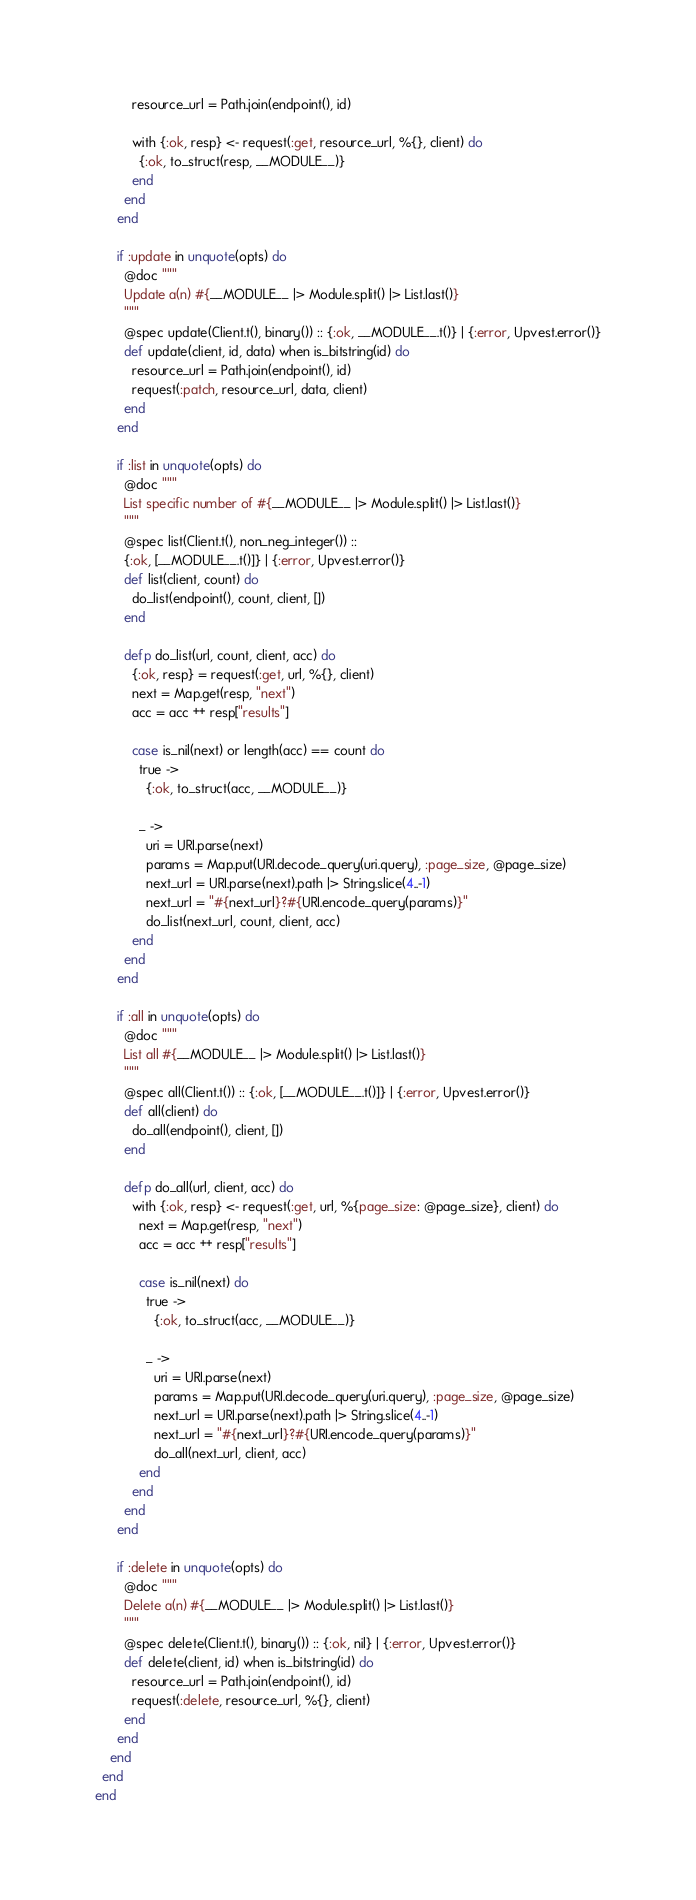Convert code to text. <code><loc_0><loc_0><loc_500><loc_500><_Elixir_>          resource_url = Path.join(endpoint(), id)

          with {:ok, resp} <- request(:get, resource_url, %{}, client) do
            {:ok, to_struct(resp, __MODULE__)}
          end
        end
      end

      if :update in unquote(opts) do
        @doc """
        Update a(n) #{__MODULE__ |> Module.split() |> List.last()}
        """
        @spec update(Client.t(), binary()) :: {:ok, __MODULE__.t()} | {:error, Upvest.error()}
        def update(client, id, data) when is_bitstring(id) do
          resource_url = Path.join(endpoint(), id)
          request(:patch, resource_url, data, client)
        end
      end

      if :list in unquote(opts) do
        @doc """
        List specific number of #{__MODULE__ |> Module.split() |> List.last()}
        """
        @spec list(Client.t(), non_neg_integer()) ::
        {:ok, [__MODULE__.t()]} | {:error, Upvest.error()}
        def list(client, count) do
          do_list(endpoint(), count, client, [])
        end

        defp do_list(url, count, client, acc) do
          {:ok, resp} = request(:get, url, %{}, client)
          next = Map.get(resp, "next")
          acc = acc ++ resp["results"]

          case is_nil(next) or length(acc) == count do
            true ->
              {:ok, to_struct(acc, __MODULE__)}

            _ ->
              uri = URI.parse(next)
              params = Map.put(URI.decode_query(uri.query), :page_size, @page_size)
              next_url = URI.parse(next).path |> String.slice(4..-1)
              next_url = "#{next_url}?#{URI.encode_query(params)}"
              do_list(next_url, count, client, acc)
          end
        end
      end

      if :all in unquote(opts) do
        @doc """
        List all #{__MODULE__ |> Module.split() |> List.last()}
        """
        @spec all(Client.t()) :: {:ok, [__MODULE__.t()]} | {:error, Upvest.error()}
        def all(client) do
          do_all(endpoint(), client, [])
        end

        defp do_all(url, client, acc) do
          with {:ok, resp} <- request(:get, url, %{page_size: @page_size}, client) do
            next = Map.get(resp, "next")
            acc = acc ++ resp["results"]

            case is_nil(next) do
              true ->
                {:ok, to_struct(acc, __MODULE__)}

              _ ->
                uri = URI.parse(next)
                params = Map.put(URI.decode_query(uri.query), :page_size, @page_size)
                next_url = URI.parse(next).path |> String.slice(4..-1)
                next_url = "#{next_url}?#{URI.encode_query(params)}"
                do_all(next_url, client, acc)
            end
          end
        end
      end

      if :delete in unquote(opts) do
        @doc """
        Delete a(n) #{__MODULE__ |> Module.split() |> List.last()}
        """
        @spec delete(Client.t(), binary()) :: {:ok, nil} | {:error, Upvest.error()}
        def delete(client, id) when is_bitstring(id) do
          resource_url = Path.join(endpoint(), id)
          request(:delete, resource_url, %{}, client)
        end
      end
    end
  end
end
</code> 